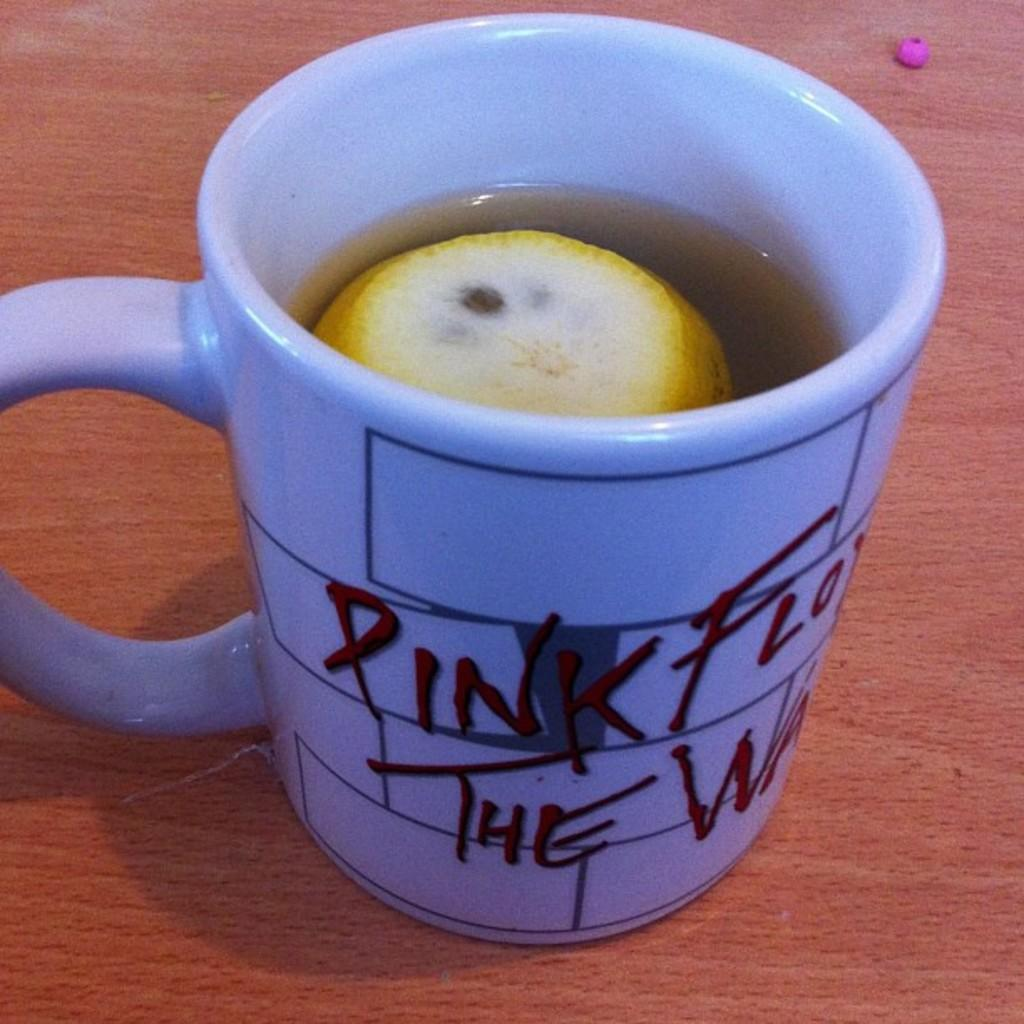<image>
Describe the image concisely. Blue cup that says PInk on it with a lemon inside. 